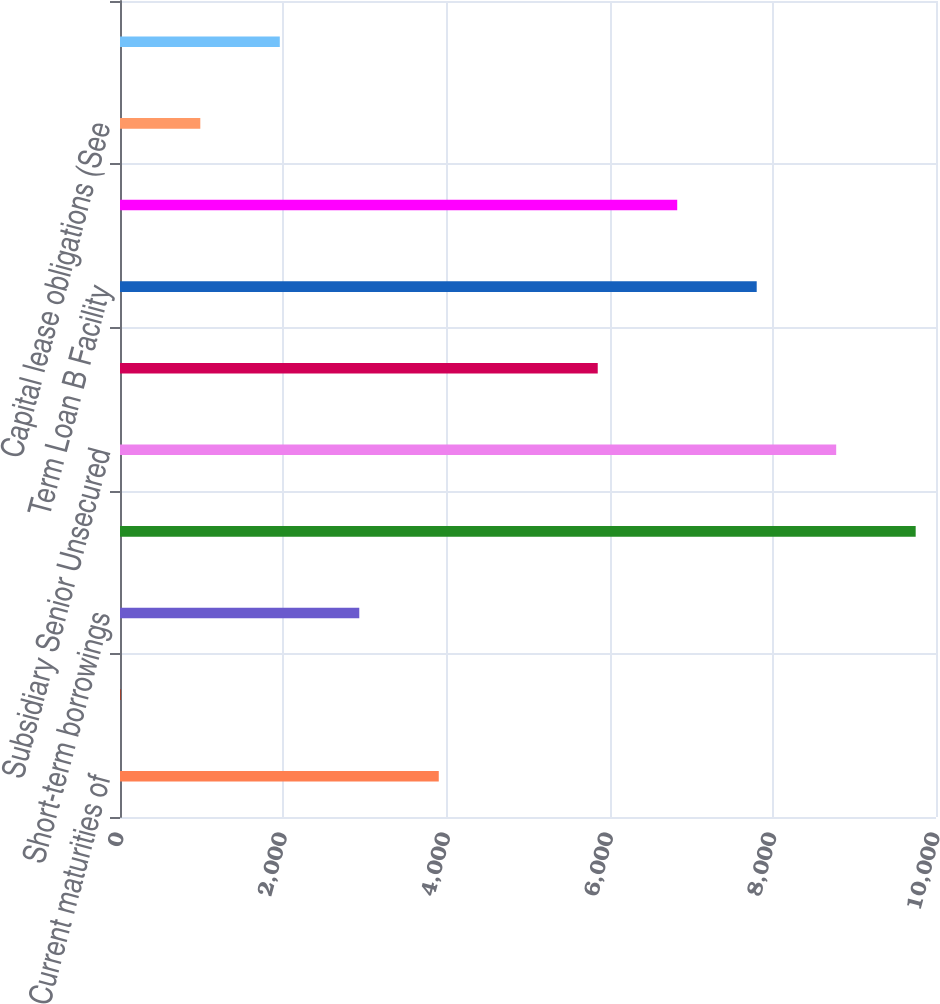Convert chart to OTSL. <chart><loc_0><loc_0><loc_500><loc_500><bar_chart><fcel>Current maturities of<fcel>Less current portion of debt<fcel>Short-term borrowings<fcel>Securitization Notes<fcel>Subsidiary Senior Unsecured<fcel>Term Loan A Facility<fcel>Term Loan B Facility<fcel>YUM Senior Unsecured Notes<fcel>Capital lease obligations (See<fcel>Less debt issuance costs and<nl><fcel>3906.4<fcel>10<fcel>2932.3<fcel>9751<fcel>8776.9<fcel>5854.6<fcel>7802.8<fcel>6828.7<fcel>984.1<fcel>1958.2<nl></chart> 